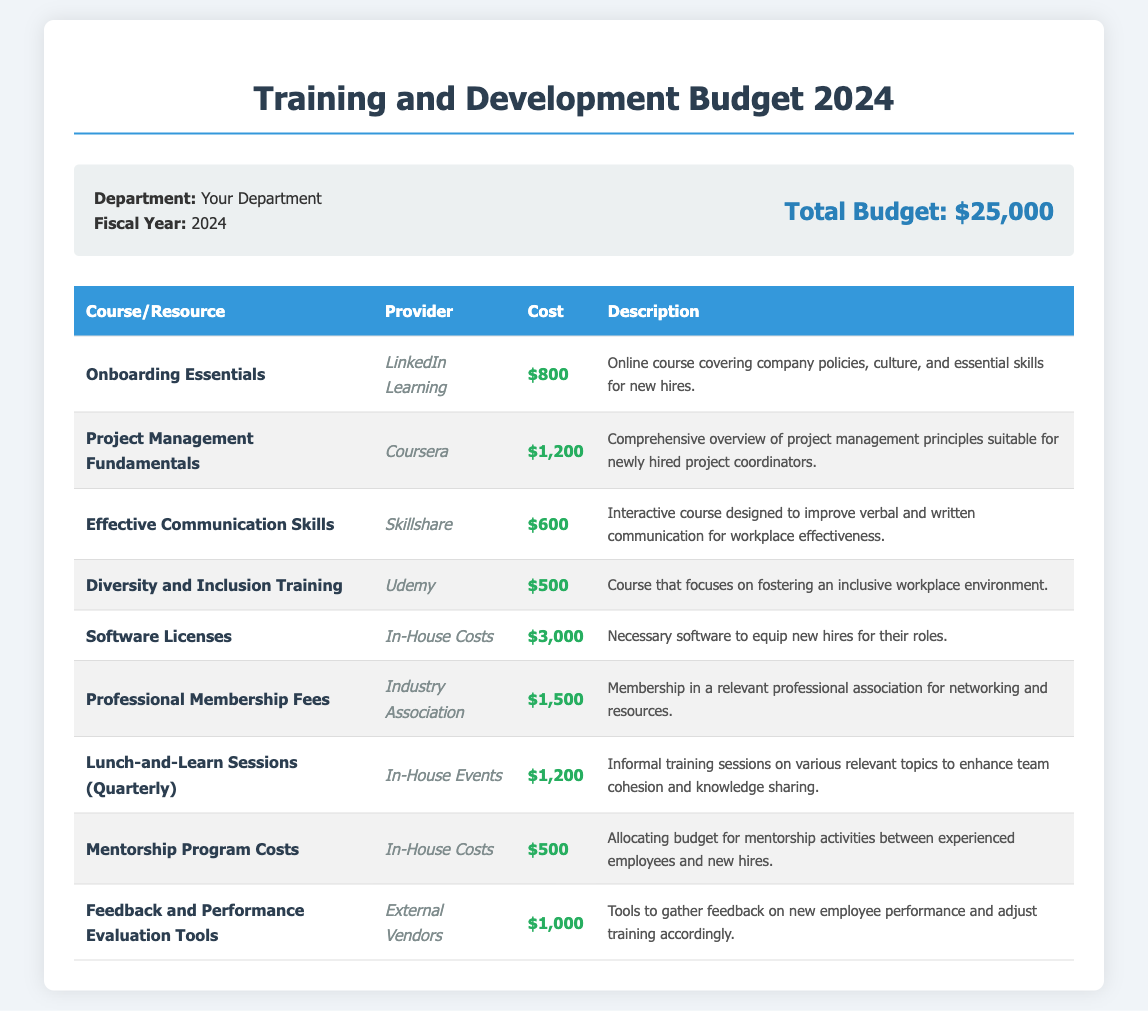What is the total budget for the Training and Development Program? The total budget is clearly stated in the budget summary section of the document as $25,000.
Answer: $25,000 Who is the provider for the "Onboarding Essentials" course? The provider for this course can be found in the table under the corresponding course name. It is LinkedIn Learning.
Answer: LinkedIn Learning How much does the "Project Management Fundamentals" course cost? The cost of this course is listed in the cost column of the table specifically for that course. It is $1,200.
Answer: $1,200 What type of training does the "Diversity and Inclusion Training" focus on? The description column for this course provides insight into its content, which is about fostering an inclusive workplace environment.
Answer: Inclusive workplace What are the total costs for the software licenses? The total cost for software licenses is mentioned in the respective row within the table, which amounts to $3,000.
Answer: $3,000 Which course is designed to improve communication skills? This information can be found by looking at the course names in the document, specifically the course titled "Effective Communication Skills."
Answer: Effective Communication Skills What is the cost for Lunch-and-Learn Sessions quarterly? The cost for these sessions can be located in the costs column of the table under that specific course, which lists $1,200.
Answer: $1,200 How many courses involve in-house costs? Counting the entries in the table that indicate "In-House Costs" as the provider reveals a total of three courses.
Answer: Three Which provider offers the "Professional Membership Fees"? The provider for this expense is given in the table under the name of the course, which is Industry Association.
Answer: Industry Association 